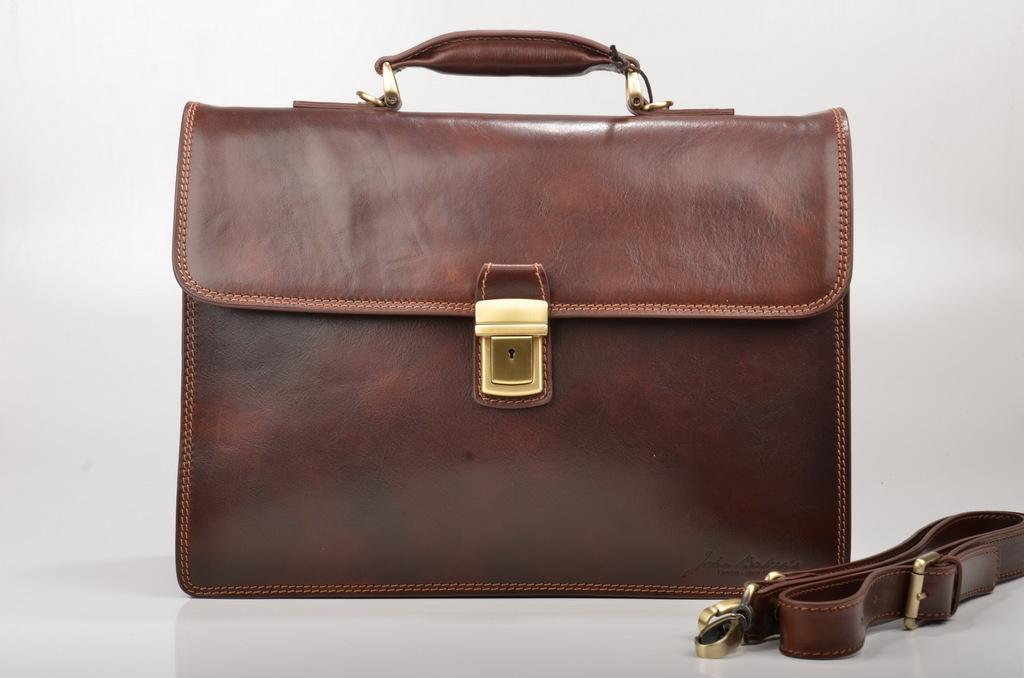What type of handbag is visible in the image? There is a brown handbag in the image. What is the color of the bag clip on the handbag? The bag clip on the handbag is gold-colored. What color is the background of the image? The background of the image is white. What type of print can be seen on the handbag in the image? There is no print visible on the handbag in the image; it is a solid brown color. How does the handbag feel in terms of comfort in the image? The image does not provide any information about the comfort of the handbag, as it is a still image and cannot convey tactile sensations. 